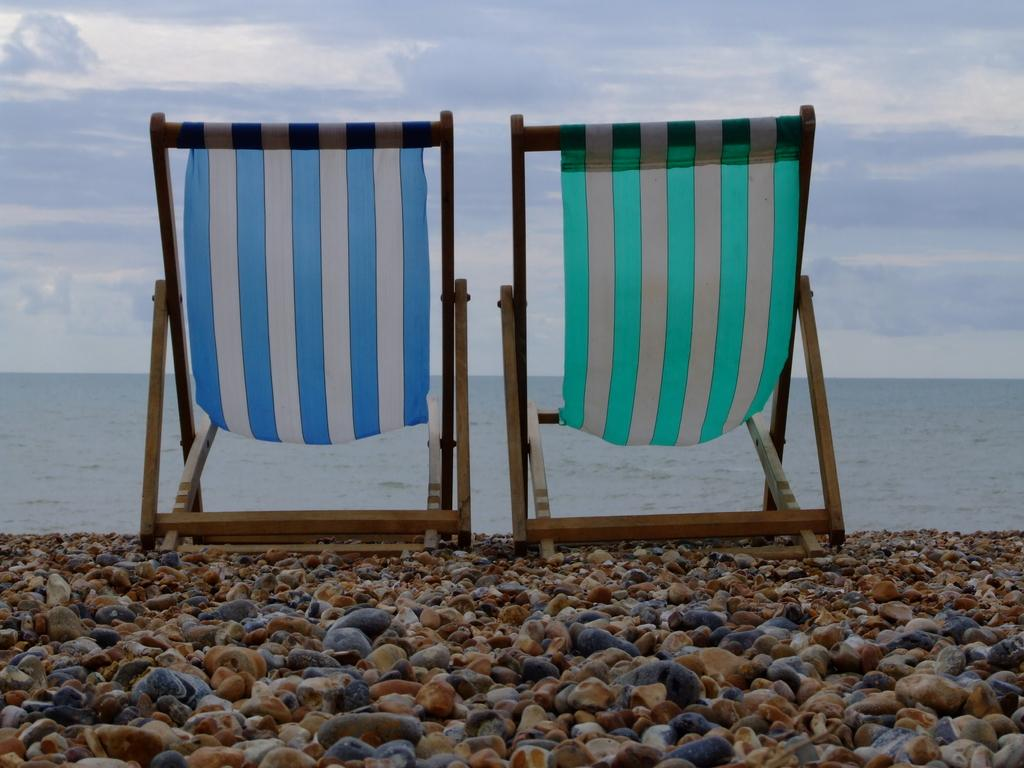What type of furniture can be seen in the image? There are chairs in the image. What other objects are present in the image? There are stones and water visible in the image. What can be seen in the background of the image? The sky is visible in the background of the image. What is the condition of the sky in the image? Clouds are present in the sky. What type of nerve can be seen in the image? There is no nerve present in the image. What scent is associated with the stones in the image? The image does not provide any information about the scent of the stones. 